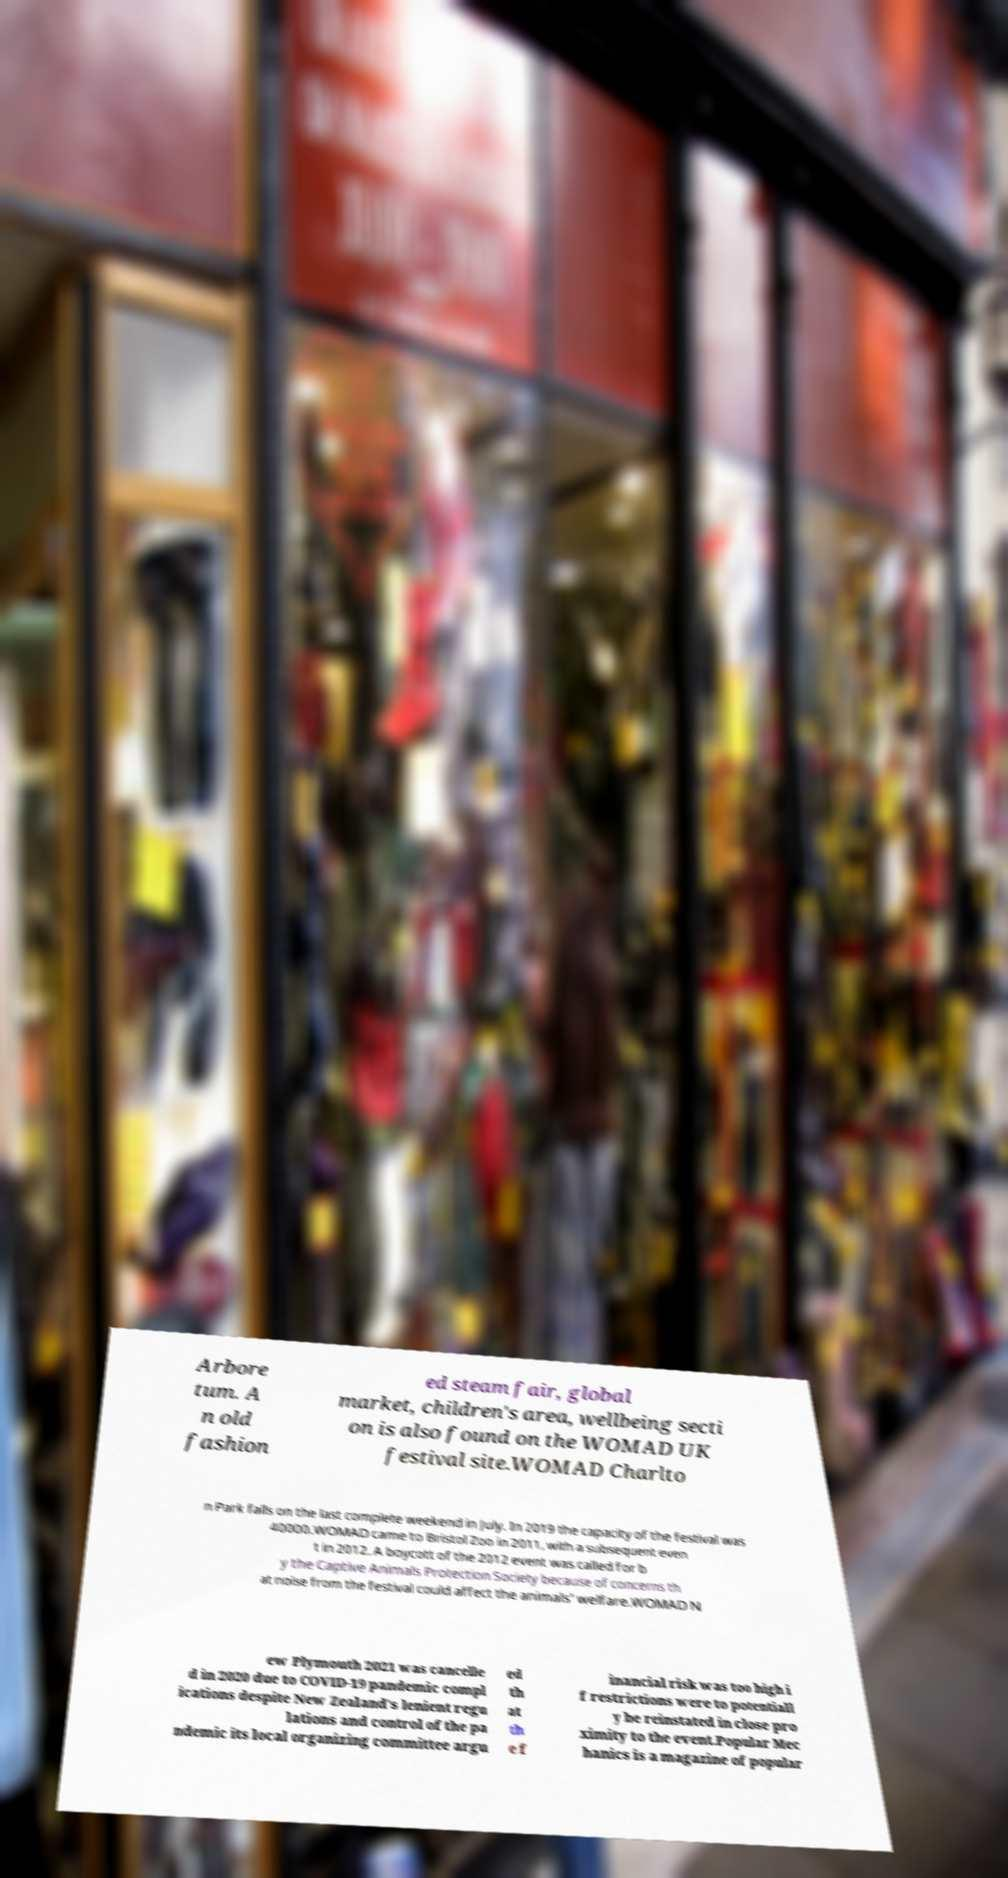Could you extract and type out the text from this image? Arbore tum. A n old fashion ed steam fair, global market, children's area, wellbeing secti on is also found on the WOMAD UK festival site.WOMAD Charlto n Park falls on the last complete weekend in July. In 2019 the capacity of the festival was 40000.WOMAD came to Bristol Zoo in 2011, with a subsequent even t in 2012. A boycott of the 2012 event was called for b y the Captive Animals Protection Society because of concerns th at noise from the festival could affect the animals' welfare.WOMAD N ew Plymouth 2021 was cancelle d in 2020 due to COVID-19 pandemic compl ications despite New Zealand's lenient regu lations and control of the pa ndemic its local organizing committee argu ed th at th e f inancial risk was too high i f restrictions were to potentiall y be reinstated in close pro ximity to the event.Popular Mec hanics is a magazine of popular 